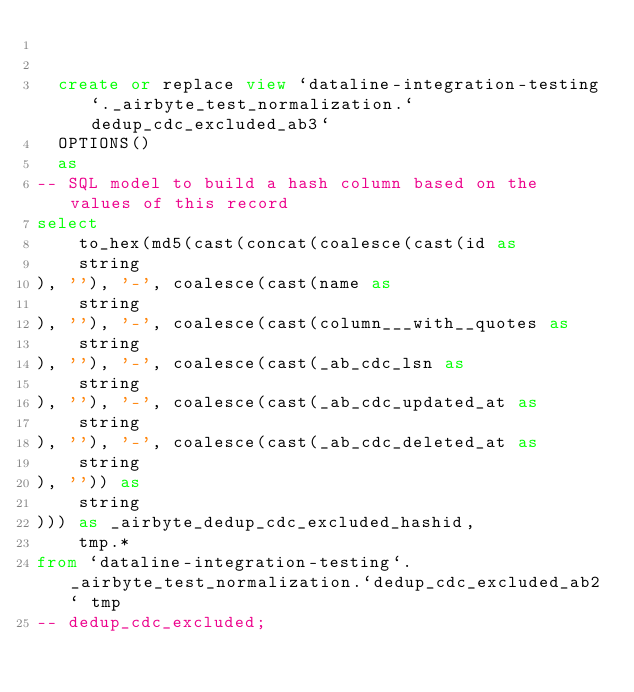<code> <loc_0><loc_0><loc_500><loc_500><_SQL_>

  create or replace view `dataline-integration-testing`._airbyte_test_normalization.`dedup_cdc_excluded_ab3`
  OPTIONS()
  as 
-- SQL model to build a hash column based on the values of this record
select
    to_hex(md5(cast(concat(coalesce(cast(id as 
    string
), ''), '-', coalesce(cast(name as 
    string
), ''), '-', coalesce(cast(column___with__quotes as 
    string
), ''), '-', coalesce(cast(_ab_cdc_lsn as 
    string
), ''), '-', coalesce(cast(_ab_cdc_updated_at as 
    string
), ''), '-', coalesce(cast(_ab_cdc_deleted_at as 
    string
), '')) as 
    string
))) as _airbyte_dedup_cdc_excluded_hashid,
    tmp.*
from `dataline-integration-testing`._airbyte_test_normalization.`dedup_cdc_excluded_ab2` tmp
-- dedup_cdc_excluded;

</code> 